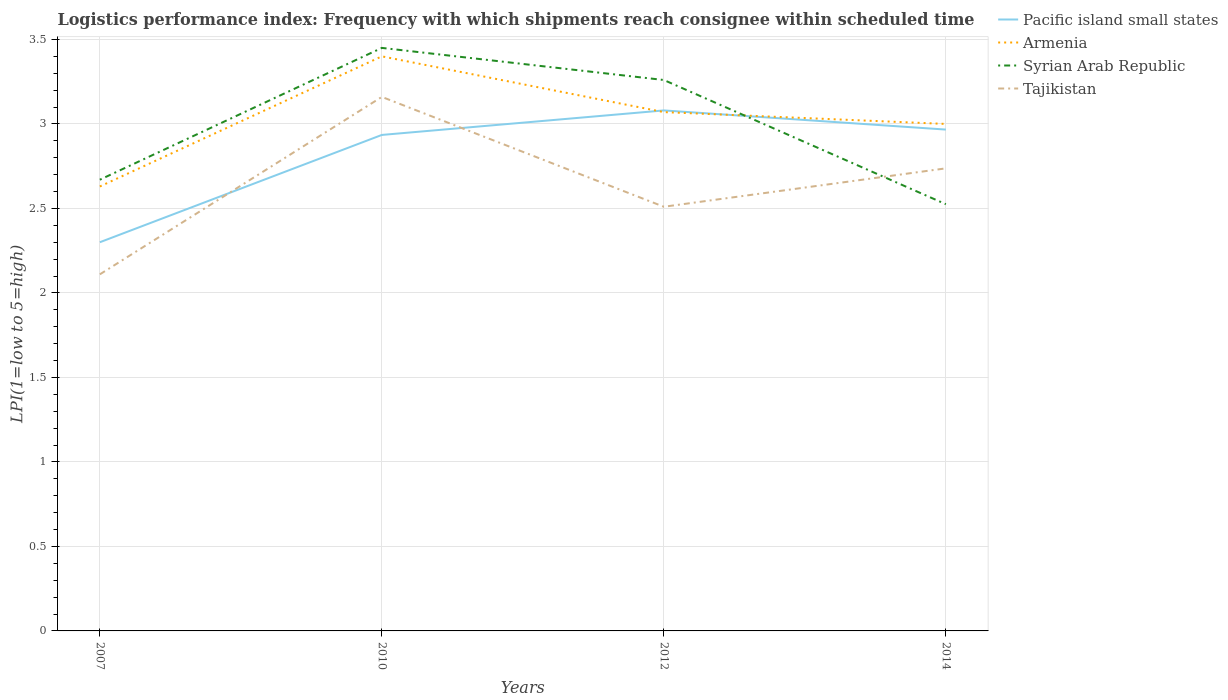Across all years, what is the maximum logistics performance index in Armenia?
Make the answer very short. 2.63. What is the total logistics performance index in Tajikistan in the graph?
Give a very brief answer. -0.4. What is the difference between the highest and the second highest logistics performance index in Syrian Arab Republic?
Keep it short and to the point. 0.92. What is the difference between the highest and the lowest logistics performance index in Pacific island small states?
Offer a terse response. 3. Is the logistics performance index in Pacific island small states strictly greater than the logistics performance index in Tajikistan over the years?
Provide a succinct answer. No. How many years are there in the graph?
Your response must be concise. 4. Are the values on the major ticks of Y-axis written in scientific E-notation?
Your response must be concise. No. How many legend labels are there?
Offer a very short reply. 4. What is the title of the graph?
Your response must be concise. Logistics performance index: Frequency with which shipments reach consignee within scheduled time. What is the label or title of the Y-axis?
Provide a short and direct response. LPI(1=low to 5=high). What is the LPI(1=low to 5=high) of Pacific island small states in 2007?
Ensure brevity in your answer.  2.3. What is the LPI(1=low to 5=high) in Armenia in 2007?
Offer a very short reply. 2.63. What is the LPI(1=low to 5=high) in Syrian Arab Republic in 2007?
Make the answer very short. 2.67. What is the LPI(1=low to 5=high) in Tajikistan in 2007?
Your response must be concise. 2.11. What is the LPI(1=low to 5=high) of Pacific island small states in 2010?
Keep it short and to the point. 2.94. What is the LPI(1=low to 5=high) of Syrian Arab Republic in 2010?
Offer a terse response. 3.45. What is the LPI(1=low to 5=high) in Tajikistan in 2010?
Make the answer very short. 3.16. What is the LPI(1=low to 5=high) of Pacific island small states in 2012?
Your response must be concise. 3.08. What is the LPI(1=low to 5=high) of Armenia in 2012?
Offer a terse response. 3.07. What is the LPI(1=low to 5=high) in Syrian Arab Republic in 2012?
Your answer should be very brief. 3.26. What is the LPI(1=low to 5=high) in Tajikistan in 2012?
Make the answer very short. 2.51. What is the LPI(1=low to 5=high) in Pacific island small states in 2014?
Provide a short and direct response. 2.97. What is the LPI(1=low to 5=high) in Armenia in 2014?
Keep it short and to the point. 3. What is the LPI(1=low to 5=high) in Syrian Arab Republic in 2014?
Provide a succinct answer. 2.53. What is the LPI(1=low to 5=high) of Tajikistan in 2014?
Give a very brief answer. 2.74. Across all years, what is the maximum LPI(1=low to 5=high) of Pacific island small states?
Provide a succinct answer. 3.08. Across all years, what is the maximum LPI(1=low to 5=high) in Armenia?
Make the answer very short. 3.4. Across all years, what is the maximum LPI(1=low to 5=high) of Syrian Arab Republic?
Your answer should be compact. 3.45. Across all years, what is the maximum LPI(1=low to 5=high) in Tajikistan?
Offer a terse response. 3.16. Across all years, what is the minimum LPI(1=low to 5=high) in Armenia?
Offer a terse response. 2.63. Across all years, what is the minimum LPI(1=low to 5=high) in Syrian Arab Republic?
Your response must be concise. 2.53. Across all years, what is the minimum LPI(1=low to 5=high) in Tajikistan?
Your answer should be compact. 2.11. What is the total LPI(1=low to 5=high) of Pacific island small states in the graph?
Provide a short and direct response. 11.28. What is the total LPI(1=low to 5=high) of Syrian Arab Republic in the graph?
Provide a short and direct response. 11.9. What is the total LPI(1=low to 5=high) in Tajikistan in the graph?
Provide a short and direct response. 10.52. What is the difference between the LPI(1=low to 5=high) in Pacific island small states in 2007 and that in 2010?
Ensure brevity in your answer.  -0.64. What is the difference between the LPI(1=low to 5=high) in Armenia in 2007 and that in 2010?
Keep it short and to the point. -0.77. What is the difference between the LPI(1=low to 5=high) of Syrian Arab Republic in 2007 and that in 2010?
Ensure brevity in your answer.  -0.78. What is the difference between the LPI(1=low to 5=high) in Tajikistan in 2007 and that in 2010?
Offer a very short reply. -1.05. What is the difference between the LPI(1=low to 5=high) of Pacific island small states in 2007 and that in 2012?
Your answer should be compact. -0.78. What is the difference between the LPI(1=low to 5=high) in Armenia in 2007 and that in 2012?
Offer a terse response. -0.44. What is the difference between the LPI(1=low to 5=high) in Syrian Arab Republic in 2007 and that in 2012?
Offer a very short reply. -0.59. What is the difference between the LPI(1=low to 5=high) in Pacific island small states in 2007 and that in 2014?
Make the answer very short. -0.67. What is the difference between the LPI(1=low to 5=high) of Armenia in 2007 and that in 2014?
Make the answer very short. -0.37. What is the difference between the LPI(1=low to 5=high) in Syrian Arab Republic in 2007 and that in 2014?
Make the answer very short. 0.14. What is the difference between the LPI(1=low to 5=high) in Tajikistan in 2007 and that in 2014?
Your answer should be compact. -0.63. What is the difference between the LPI(1=low to 5=high) in Pacific island small states in 2010 and that in 2012?
Offer a very short reply. -0.14. What is the difference between the LPI(1=low to 5=high) in Armenia in 2010 and that in 2012?
Give a very brief answer. 0.33. What is the difference between the LPI(1=low to 5=high) of Syrian Arab Republic in 2010 and that in 2012?
Your answer should be very brief. 0.19. What is the difference between the LPI(1=low to 5=high) of Tajikistan in 2010 and that in 2012?
Make the answer very short. 0.65. What is the difference between the LPI(1=low to 5=high) of Pacific island small states in 2010 and that in 2014?
Provide a succinct answer. -0.03. What is the difference between the LPI(1=low to 5=high) of Armenia in 2010 and that in 2014?
Your answer should be very brief. 0.4. What is the difference between the LPI(1=low to 5=high) of Syrian Arab Republic in 2010 and that in 2014?
Your answer should be compact. 0.93. What is the difference between the LPI(1=low to 5=high) in Tajikistan in 2010 and that in 2014?
Your answer should be compact. 0.42. What is the difference between the LPI(1=low to 5=high) of Pacific island small states in 2012 and that in 2014?
Keep it short and to the point. 0.11. What is the difference between the LPI(1=low to 5=high) in Armenia in 2012 and that in 2014?
Provide a short and direct response. 0.07. What is the difference between the LPI(1=low to 5=high) in Syrian Arab Republic in 2012 and that in 2014?
Provide a short and direct response. 0.73. What is the difference between the LPI(1=low to 5=high) of Tajikistan in 2012 and that in 2014?
Your response must be concise. -0.23. What is the difference between the LPI(1=low to 5=high) of Pacific island small states in 2007 and the LPI(1=low to 5=high) of Syrian Arab Republic in 2010?
Provide a short and direct response. -1.15. What is the difference between the LPI(1=low to 5=high) in Pacific island small states in 2007 and the LPI(1=low to 5=high) in Tajikistan in 2010?
Your answer should be compact. -0.86. What is the difference between the LPI(1=low to 5=high) of Armenia in 2007 and the LPI(1=low to 5=high) of Syrian Arab Republic in 2010?
Keep it short and to the point. -0.82. What is the difference between the LPI(1=low to 5=high) of Armenia in 2007 and the LPI(1=low to 5=high) of Tajikistan in 2010?
Ensure brevity in your answer.  -0.53. What is the difference between the LPI(1=low to 5=high) in Syrian Arab Republic in 2007 and the LPI(1=low to 5=high) in Tajikistan in 2010?
Keep it short and to the point. -0.49. What is the difference between the LPI(1=low to 5=high) of Pacific island small states in 2007 and the LPI(1=low to 5=high) of Armenia in 2012?
Make the answer very short. -0.77. What is the difference between the LPI(1=low to 5=high) in Pacific island small states in 2007 and the LPI(1=low to 5=high) in Syrian Arab Republic in 2012?
Provide a succinct answer. -0.96. What is the difference between the LPI(1=low to 5=high) of Pacific island small states in 2007 and the LPI(1=low to 5=high) of Tajikistan in 2012?
Offer a very short reply. -0.21. What is the difference between the LPI(1=low to 5=high) in Armenia in 2007 and the LPI(1=low to 5=high) in Syrian Arab Republic in 2012?
Ensure brevity in your answer.  -0.63. What is the difference between the LPI(1=low to 5=high) of Armenia in 2007 and the LPI(1=low to 5=high) of Tajikistan in 2012?
Ensure brevity in your answer.  0.12. What is the difference between the LPI(1=low to 5=high) of Syrian Arab Republic in 2007 and the LPI(1=low to 5=high) of Tajikistan in 2012?
Your answer should be compact. 0.16. What is the difference between the LPI(1=low to 5=high) in Pacific island small states in 2007 and the LPI(1=low to 5=high) in Armenia in 2014?
Keep it short and to the point. -0.7. What is the difference between the LPI(1=low to 5=high) of Pacific island small states in 2007 and the LPI(1=low to 5=high) of Syrian Arab Republic in 2014?
Provide a short and direct response. -0.23. What is the difference between the LPI(1=low to 5=high) in Pacific island small states in 2007 and the LPI(1=low to 5=high) in Tajikistan in 2014?
Provide a succinct answer. -0.44. What is the difference between the LPI(1=low to 5=high) in Armenia in 2007 and the LPI(1=low to 5=high) in Syrian Arab Republic in 2014?
Your response must be concise. 0.1. What is the difference between the LPI(1=low to 5=high) of Armenia in 2007 and the LPI(1=low to 5=high) of Tajikistan in 2014?
Keep it short and to the point. -0.11. What is the difference between the LPI(1=low to 5=high) of Syrian Arab Republic in 2007 and the LPI(1=low to 5=high) of Tajikistan in 2014?
Provide a succinct answer. -0.07. What is the difference between the LPI(1=low to 5=high) in Pacific island small states in 2010 and the LPI(1=low to 5=high) in Armenia in 2012?
Provide a succinct answer. -0.14. What is the difference between the LPI(1=low to 5=high) in Pacific island small states in 2010 and the LPI(1=low to 5=high) in Syrian Arab Republic in 2012?
Offer a very short reply. -0.33. What is the difference between the LPI(1=low to 5=high) of Pacific island small states in 2010 and the LPI(1=low to 5=high) of Tajikistan in 2012?
Give a very brief answer. 0.42. What is the difference between the LPI(1=low to 5=high) of Armenia in 2010 and the LPI(1=low to 5=high) of Syrian Arab Republic in 2012?
Your answer should be very brief. 0.14. What is the difference between the LPI(1=low to 5=high) of Armenia in 2010 and the LPI(1=low to 5=high) of Tajikistan in 2012?
Give a very brief answer. 0.89. What is the difference between the LPI(1=low to 5=high) in Syrian Arab Republic in 2010 and the LPI(1=low to 5=high) in Tajikistan in 2012?
Provide a succinct answer. 0.94. What is the difference between the LPI(1=low to 5=high) of Pacific island small states in 2010 and the LPI(1=low to 5=high) of Armenia in 2014?
Keep it short and to the point. -0.07. What is the difference between the LPI(1=low to 5=high) in Pacific island small states in 2010 and the LPI(1=low to 5=high) in Syrian Arab Republic in 2014?
Ensure brevity in your answer.  0.41. What is the difference between the LPI(1=low to 5=high) in Pacific island small states in 2010 and the LPI(1=low to 5=high) in Tajikistan in 2014?
Provide a succinct answer. 0.2. What is the difference between the LPI(1=low to 5=high) in Armenia in 2010 and the LPI(1=low to 5=high) in Syrian Arab Republic in 2014?
Provide a short and direct response. 0.88. What is the difference between the LPI(1=low to 5=high) in Armenia in 2010 and the LPI(1=low to 5=high) in Tajikistan in 2014?
Keep it short and to the point. 0.66. What is the difference between the LPI(1=low to 5=high) of Syrian Arab Republic in 2010 and the LPI(1=low to 5=high) of Tajikistan in 2014?
Provide a short and direct response. 0.71. What is the difference between the LPI(1=low to 5=high) of Pacific island small states in 2012 and the LPI(1=low to 5=high) of Armenia in 2014?
Your response must be concise. 0.08. What is the difference between the LPI(1=low to 5=high) of Pacific island small states in 2012 and the LPI(1=low to 5=high) of Syrian Arab Republic in 2014?
Your answer should be very brief. 0.56. What is the difference between the LPI(1=low to 5=high) in Pacific island small states in 2012 and the LPI(1=low to 5=high) in Tajikistan in 2014?
Make the answer very short. 0.34. What is the difference between the LPI(1=low to 5=high) of Armenia in 2012 and the LPI(1=low to 5=high) of Syrian Arab Republic in 2014?
Make the answer very short. 0.55. What is the difference between the LPI(1=low to 5=high) in Armenia in 2012 and the LPI(1=low to 5=high) in Tajikistan in 2014?
Provide a succinct answer. 0.33. What is the difference between the LPI(1=low to 5=high) in Syrian Arab Republic in 2012 and the LPI(1=low to 5=high) in Tajikistan in 2014?
Your response must be concise. 0.52. What is the average LPI(1=low to 5=high) in Pacific island small states per year?
Offer a very short reply. 2.82. What is the average LPI(1=low to 5=high) of Armenia per year?
Provide a short and direct response. 3.02. What is the average LPI(1=low to 5=high) in Syrian Arab Republic per year?
Keep it short and to the point. 2.98. What is the average LPI(1=low to 5=high) of Tajikistan per year?
Make the answer very short. 2.63. In the year 2007, what is the difference between the LPI(1=low to 5=high) of Pacific island small states and LPI(1=low to 5=high) of Armenia?
Your answer should be compact. -0.33. In the year 2007, what is the difference between the LPI(1=low to 5=high) in Pacific island small states and LPI(1=low to 5=high) in Syrian Arab Republic?
Your answer should be compact. -0.37. In the year 2007, what is the difference between the LPI(1=low to 5=high) in Pacific island small states and LPI(1=low to 5=high) in Tajikistan?
Ensure brevity in your answer.  0.19. In the year 2007, what is the difference between the LPI(1=low to 5=high) in Armenia and LPI(1=low to 5=high) in Syrian Arab Republic?
Your answer should be very brief. -0.04. In the year 2007, what is the difference between the LPI(1=low to 5=high) in Armenia and LPI(1=low to 5=high) in Tajikistan?
Keep it short and to the point. 0.52. In the year 2007, what is the difference between the LPI(1=low to 5=high) in Syrian Arab Republic and LPI(1=low to 5=high) in Tajikistan?
Provide a short and direct response. 0.56. In the year 2010, what is the difference between the LPI(1=low to 5=high) of Pacific island small states and LPI(1=low to 5=high) of Armenia?
Your answer should be compact. -0.47. In the year 2010, what is the difference between the LPI(1=low to 5=high) of Pacific island small states and LPI(1=low to 5=high) of Syrian Arab Republic?
Offer a terse response. -0.52. In the year 2010, what is the difference between the LPI(1=low to 5=high) in Pacific island small states and LPI(1=low to 5=high) in Tajikistan?
Your answer should be very brief. -0.23. In the year 2010, what is the difference between the LPI(1=low to 5=high) of Armenia and LPI(1=low to 5=high) of Tajikistan?
Your answer should be compact. 0.24. In the year 2010, what is the difference between the LPI(1=low to 5=high) of Syrian Arab Republic and LPI(1=low to 5=high) of Tajikistan?
Your response must be concise. 0.29. In the year 2012, what is the difference between the LPI(1=low to 5=high) in Pacific island small states and LPI(1=low to 5=high) in Armenia?
Offer a terse response. 0.01. In the year 2012, what is the difference between the LPI(1=low to 5=high) in Pacific island small states and LPI(1=low to 5=high) in Syrian Arab Republic?
Provide a succinct answer. -0.18. In the year 2012, what is the difference between the LPI(1=low to 5=high) of Pacific island small states and LPI(1=low to 5=high) of Tajikistan?
Your answer should be very brief. 0.57. In the year 2012, what is the difference between the LPI(1=low to 5=high) in Armenia and LPI(1=low to 5=high) in Syrian Arab Republic?
Your answer should be very brief. -0.19. In the year 2012, what is the difference between the LPI(1=low to 5=high) of Armenia and LPI(1=low to 5=high) of Tajikistan?
Provide a short and direct response. 0.56. In the year 2012, what is the difference between the LPI(1=low to 5=high) in Syrian Arab Republic and LPI(1=low to 5=high) in Tajikistan?
Offer a very short reply. 0.75. In the year 2014, what is the difference between the LPI(1=low to 5=high) in Pacific island small states and LPI(1=low to 5=high) in Armenia?
Offer a very short reply. -0.03. In the year 2014, what is the difference between the LPI(1=low to 5=high) in Pacific island small states and LPI(1=low to 5=high) in Syrian Arab Republic?
Keep it short and to the point. 0.44. In the year 2014, what is the difference between the LPI(1=low to 5=high) in Pacific island small states and LPI(1=low to 5=high) in Tajikistan?
Offer a terse response. 0.23. In the year 2014, what is the difference between the LPI(1=low to 5=high) in Armenia and LPI(1=low to 5=high) in Syrian Arab Republic?
Give a very brief answer. 0.47. In the year 2014, what is the difference between the LPI(1=low to 5=high) in Armenia and LPI(1=low to 5=high) in Tajikistan?
Give a very brief answer. 0.26. In the year 2014, what is the difference between the LPI(1=low to 5=high) in Syrian Arab Republic and LPI(1=low to 5=high) in Tajikistan?
Make the answer very short. -0.21. What is the ratio of the LPI(1=low to 5=high) of Pacific island small states in 2007 to that in 2010?
Give a very brief answer. 0.78. What is the ratio of the LPI(1=low to 5=high) in Armenia in 2007 to that in 2010?
Keep it short and to the point. 0.77. What is the ratio of the LPI(1=low to 5=high) of Syrian Arab Republic in 2007 to that in 2010?
Give a very brief answer. 0.77. What is the ratio of the LPI(1=low to 5=high) of Tajikistan in 2007 to that in 2010?
Keep it short and to the point. 0.67. What is the ratio of the LPI(1=low to 5=high) of Pacific island small states in 2007 to that in 2012?
Your answer should be very brief. 0.75. What is the ratio of the LPI(1=low to 5=high) in Armenia in 2007 to that in 2012?
Offer a very short reply. 0.86. What is the ratio of the LPI(1=low to 5=high) in Syrian Arab Republic in 2007 to that in 2012?
Give a very brief answer. 0.82. What is the ratio of the LPI(1=low to 5=high) in Tajikistan in 2007 to that in 2012?
Provide a short and direct response. 0.84. What is the ratio of the LPI(1=low to 5=high) in Pacific island small states in 2007 to that in 2014?
Your response must be concise. 0.78. What is the ratio of the LPI(1=low to 5=high) of Armenia in 2007 to that in 2014?
Keep it short and to the point. 0.88. What is the ratio of the LPI(1=low to 5=high) of Syrian Arab Republic in 2007 to that in 2014?
Ensure brevity in your answer.  1.06. What is the ratio of the LPI(1=low to 5=high) in Tajikistan in 2007 to that in 2014?
Keep it short and to the point. 0.77. What is the ratio of the LPI(1=low to 5=high) in Pacific island small states in 2010 to that in 2012?
Offer a very short reply. 0.95. What is the ratio of the LPI(1=low to 5=high) of Armenia in 2010 to that in 2012?
Your response must be concise. 1.11. What is the ratio of the LPI(1=low to 5=high) of Syrian Arab Republic in 2010 to that in 2012?
Your response must be concise. 1.06. What is the ratio of the LPI(1=low to 5=high) in Tajikistan in 2010 to that in 2012?
Provide a short and direct response. 1.26. What is the ratio of the LPI(1=low to 5=high) in Pacific island small states in 2010 to that in 2014?
Provide a short and direct response. 0.99. What is the ratio of the LPI(1=low to 5=high) in Armenia in 2010 to that in 2014?
Offer a terse response. 1.13. What is the ratio of the LPI(1=low to 5=high) of Syrian Arab Republic in 2010 to that in 2014?
Offer a very short reply. 1.37. What is the ratio of the LPI(1=low to 5=high) of Tajikistan in 2010 to that in 2014?
Offer a very short reply. 1.15. What is the ratio of the LPI(1=low to 5=high) of Pacific island small states in 2012 to that in 2014?
Make the answer very short. 1.04. What is the ratio of the LPI(1=low to 5=high) in Armenia in 2012 to that in 2014?
Your answer should be very brief. 1.02. What is the ratio of the LPI(1=low to 5=high) of Syrian Arab Republic in 2012 to that in 2014?
Give a very brief answer. 1.29. What is the ratio of the LPI(1=low to 5=high) in Tajikistan in 2012 to that in 2014?
Your response must be concise. 0.92. What is the difference between the highest and the second highest LPI(1=low to 5=high) in Pacific island small states?
Your answer should be very brief. 0.11. What is the difference between the highest and the second highest LPI(1=low to 5=high) of Armenia?
Your answer should be compact. 0.33. What is the difference between the highest and the second highest LPI(1=low to 5=high) of Syrian Arab Republic?
Your answer should be compact. 0.19. What is the difference between the highest and the second highest LPI(1=low to 5=high) in Tajikistan?
Offer a terse response. 0.42. What is the difference between the highest and the lowest LPI(1=low to 5=high) of Pacific island small states?
Give a very brief answer. 0.78. What is the difference between the highest and the lowest LPI(1=low to 5=high) of Armenia?
Your response must be concise. 0.77. What is the difference between the highest and the lowest LPI(1=low to 5=high) in Syrian Arab Republic?
Provide a succinct answer. 0.93. 